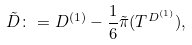Convert formula to latex. <formula><loc_0><loc_0><loc_500><loc_500>\tilde { D } \colon = D ^ { ( 1 ) } - \frac { 1 } { 6 } \tilde { \pi } ( T ^ { D ^ { ( 1 ) } } ) ,</formula> 